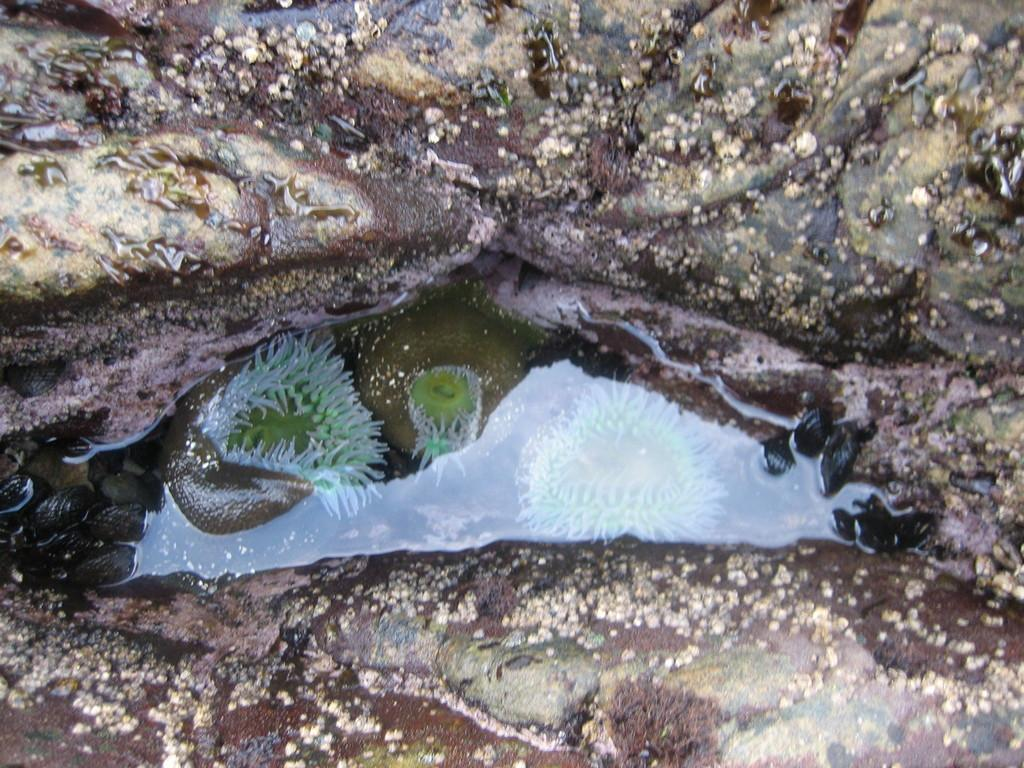What type of natural elements can be seen in the image? There are rocks and water in the image. What is the water in the image filled with? Marine organisms are present in the water. What type of floor can be seen in the image? There is no floor present in the image; it features rocks and water. How many bubbles can be seen in the image? There are no bubbles visible in the image. 